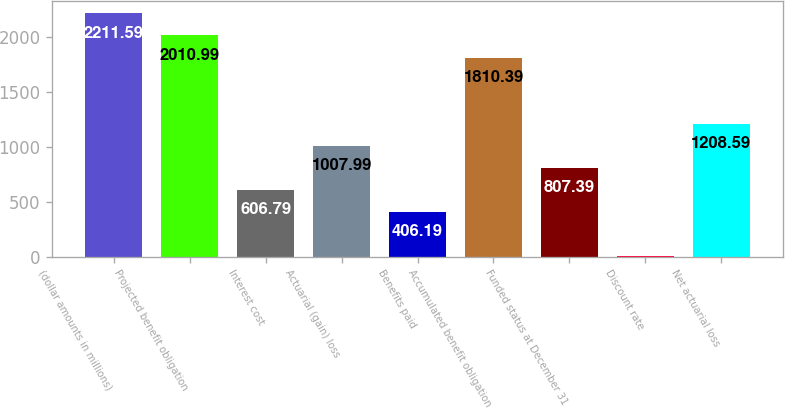Convert chart. <chart><loc_0><loc_0><loc_500><loc_500><bar_chart><fcel>(dollar amounts in millions)<fcel>Projected benefit obligation<fcel>Interest cost<fcel>Actuarial (gain) loss<fcel>Benefits paid<fcel>Accumulated benefit obligation<fcel>Funded status at December 31<fcel>Discount rate<fcel>Net actuarial loss<nl><fcel>2211.59<fcel>2010.99<fcel>606.79<fcel>1007.99<fcel>406.19<fcel>1810.39<fcel>807.39<fcel>4.99<fcel>1208.59<nl></chart> 